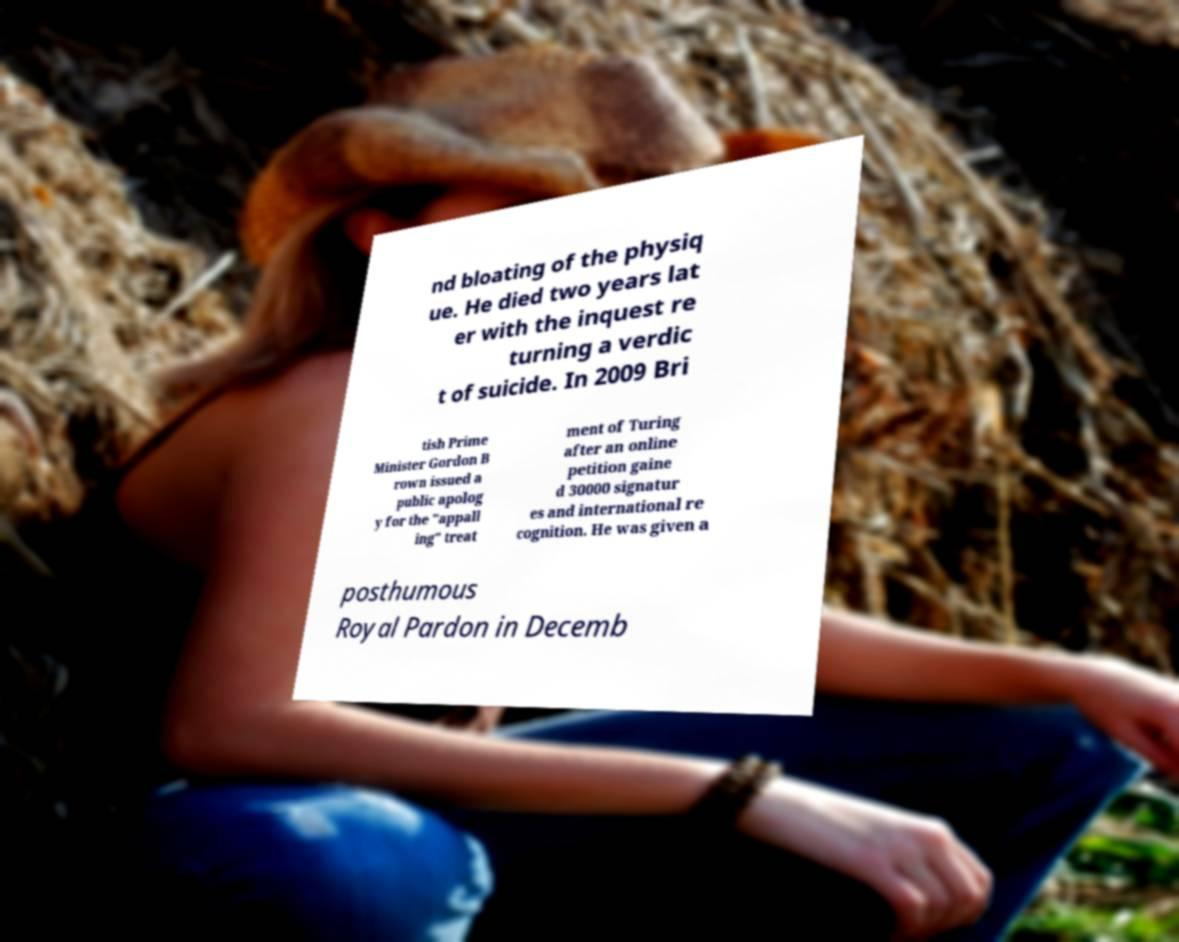Can you read and provide the text displayed in the image?This photo seems to have some interesting text. Can you extract and type it out for me? nd bloating of the physiq ue. He died two years lat er with the inquest re turning a verdic t of suicide. In 2009 Bri tish Prime Minister Gordon B rown issued a public apolog y for the "appall ing" treat ment of Turing after an online petition gaine d 30000 signatur es and international re cognition. He was given a posthumous Royal Pardon in Decemb 